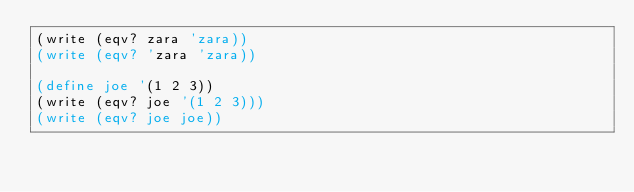<code> <loc_0><loc_0><loc_500><loc_500><_Scheme_>(write (eqv? zara 'zara))
(write (eqv? 'zara 'zara))

(define joe '(1 2 3))
(write (eqv? joe '(1 2 3)))
(write (eqv? joe joe))
</code> 